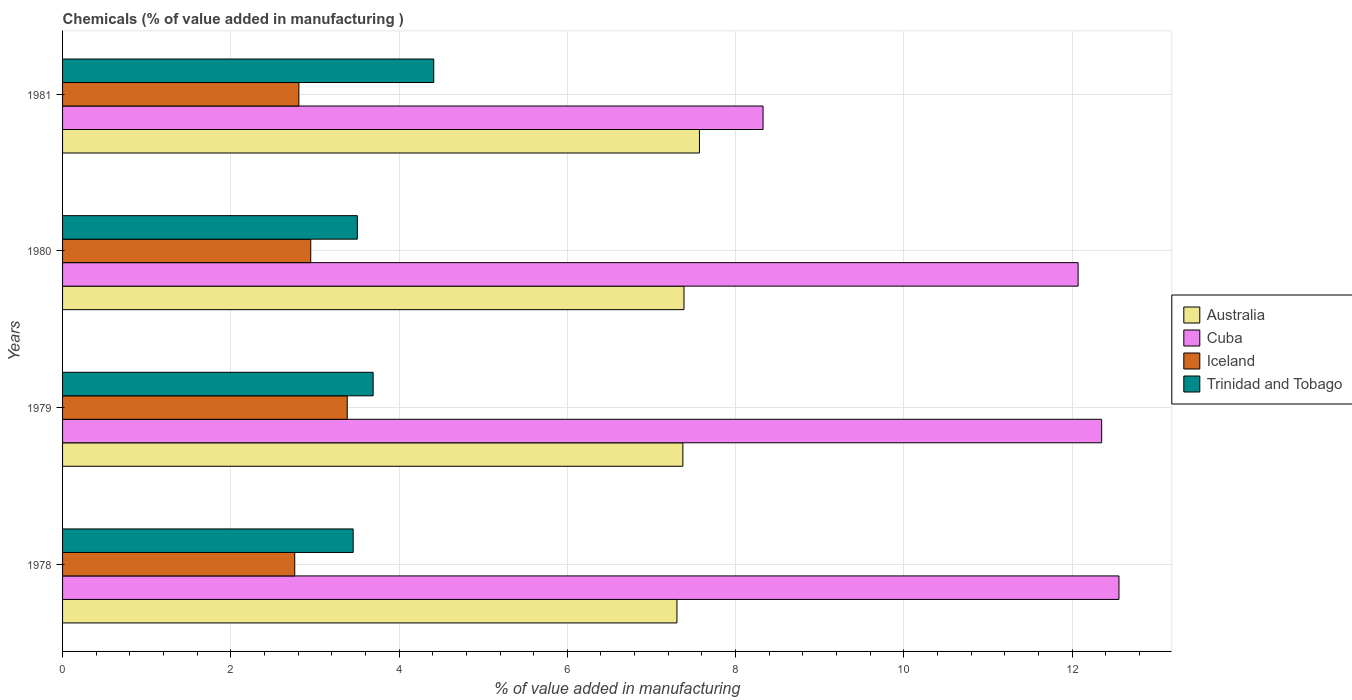How many groups of bars are there?
Give a very brief answer. 4. Are the number of bars per tick equal to the number of legend labels?
Your response must be concise. Yes. How many bars are there on the 1st tick from the top?
Give a very brief answer. 4. What is the value added in manufacturing chemicals in Australia in 1978?
Keep it short and to the point. 7.3. Across all years, what is the maximum value added in manufacturing chemicals in Cuba?
Your answer should be very brief. 12.56. Across all years, what is the minimum value added in manufacturing chemicals in Trinidad and Tobago?
Ensure brevity in your answer.  3.45. In which year was the value added in manufacturing chemicals in Cuba maximum?
Your response must be concise. 1978. In which year was the value added in manufacturing chemicals in Australia minimum?
Give a very brief answer. 1978. What is the total value added in manufacturing chemicals in Trinidad and Tobago in the graph?
Give a very brief answer. 15.06. What is the difference between the value added in manufacturing chemicals in Iceland in 1978 and that in 1979?
Your answer should be compact. -0.62. What is the difference between the value added in manufacturing chemicals in Trinidad and Tobago in 1981 and the value added in manufacturing chemicals in Cuba in 1980?
Give a very brief answer. -7.66. What is the average value added in manufacturing chemicals in Australia per year?
Your answer should be very brief. 7.41. In the year 1979, what is the difference between the value added in manufacturing chemicals in Cuba and value added in manufacturing chemicals in Trinidad and Tobago?
Provide a short and direct response. 8.66. In how many years, is the value added in manufacturing chemicals in Trinidad and Tobago greater than 10 %?
Offer a terse response. 0. What is the ratio of the value added in manufacturing chemicals in Trinidad and Tobago in 1978 to that in 1979?
Offer a terse response. 0.94. Is the value added in manufacturing chemicals in Cuba in 1978 less than that in 1981?
Your response must be concise. No. What is the difference between the highest and the second highest value added in manufacturing chemicals in Trinidad and Tobago?
Provide a short and direct response. 0.72. What is the difference between the highest and the lowest value added in manufacturing chemicals in Australia?
Give a very brief answer. 0.27. In how many years, is the value added in manufacturing chemicals in Australia greater than the average value added in manufacturing chemicals in Australia taken over all years?
Ensure brevity in your answer.  1. Is the sum of the value added in manufacturing chemicals in Trinidad and Tobago in 1978 and 1981 greater than the maximum value added in manufacturing chemicals in Cuba across all years?
Your answer should be very brief. No. What does the 1st bar from the top in 1979 represents?
Offer a very short reply. Trinidad and Tobago. What does the 3rd bar from the bottom in 1981 represents?
Make the answer very short. Iceland. How many bars are there?
Ensure brevity in your answer.  16. How many years are there in the graph?
Give a very brief answer. 4. What is the difference between two consecutive major ticks on the X-axis?
Your answer should be compact. 2. Are the values on the major ticks of X-axis written in scientific E-notation?
Your response must be concise. No. Does the graph contain any zero values?
Make the answer very short. No. Does the graph contain grids?
Provide a succinct answer. Yes. How many legend labels are there?
Your answer should be compact. 4. What is the title of the graph?
Provide a short and direct response. Chemicals (% of value added in manufacturing ). What is the label or title of the X-axis?
Offer a very short reply. % of value added in manufacturing. What is the % of value added in manufacturing of Australia in 1978?
Make the answer very short. 7.3. What is the % of value added in manufacturing in Cuba in 1978?
Your answer should be compact. 12.56. What is the % of value added in manufacturing in Iceland in 1978?
Your answer should be compact. 2.76. What is the % of value added in manufacturing in Trinidad and Tobago in 1978?
Your response must be concise. 3.45. What is the % of value added in manufacturing in Australia in 1979?
Your answer should be very brief. 7.37. What is the % of value added in manufacturing of Cuba in 1979?
Provide a short and direct response. 12.35. What is the % of value added in manufacturing of Iceland in 1979?
Ensure brevity in your answer.  3.38. What is the % of value added in manufacturing of Trinidad and Tobago in 1979?
Offer a very short reply. 3.69. What is the % of value added in manufacturing of Australia in 1980?
Keep it short and to the point. 7.39. What is the % of value added in manufacturing of Cuba in 1980?
Make the answer very short. 12.07. What is the % of value added in manufacturing in Iceland in 1980?
Provide a succinct answer. 2.95. What is the % of value added in manufacturing in Trinidad and Tobago in 1980?
Your answer should be very brief. 3.5. What is the % of value added in manufacturing of Australia in 1981?
Keep it short and to the point. 7.57. What is the % of value added in manufacturing in Cuba in 1981?
Provide a succinct answer. 8.33. What is the % of value added in manufacturing in Iceland in 1981?
Provide a succinct answer. 2.81. What is the % of value added in manufacturing in Trinidad and Tobago in 1981?
Offer a very short reply. 4.41. Across all years, what is the maximum % of value added in manufacturing of Australia?
Offer a very short reply. 7.57. Across all years, what is the maximum % of value added in manufacturing in Cuba?
Give a very brief answer. 12.56. Across all years, what is the maximum % of value added in manufacturing of Iceland?
Offer a terse response. 3.38. Across all years, what is the maximum % of value added in manufacturing of Trinidad and Tobago?
Your answer should be very brief. 4.41. Across all years, what is the minimum % of value added in manufacturing of Australia?
Offer a very short reply. 7.3. Across all years, what is the minimum % of value added in manufacturing in Cuba?
Make the answer very short. 8.33. Across all years, what is the minimum % of value added in manufacturing of Iceland?
Offer a terse response. 2.76. Across all years, what is the minimum % of value added in manufacturing of Trinidad and Tobago?
Your response must be concise. 3.45. What is the total % of value added in manufacturing in Australia in the graph?
Your answer should be very brief. 29.63. What is the total % of value added in manufacturing in Cuba in the graph?
Offer a very short reply. 45.31. What is the total % of value added in manufacturing of Iceland in the graph?
Keep it short and to the point. 11.9. What is the total % of value added in manufacturing of Trinidad and Tobago in the graph?
Give a very brief answer. 15.06. What is the difference between the % of value added in manufacturing in Australia in 1978 and that in 1979?
Keep it short and to the point. -0.07. What is the difference between the % of value added in manufacturing of Cuba in 1978 and that in 1979?
Keep it short and to the point. 0.21. What is the difference between the % of value added in manufacturing of Iceland in 1978 and that in 1979?
Provide a succinct answer. -0.62. What is the difference between the % of value added in manufacturing in Trinidad and Tobago in 1978 and that in 1979?
Offer a terse response. -0.24. What is the difference between the % of value added in manufacturing of Australia in 1978 and that in 1980?
Your answer should be very brief. -0.08. What is the difference between the % of value added in manufacturing in Cuba in 1978 and that in 1980?
Your answer should be compact. 0.49. What is the difference between the % of value added in manufacturing in Iceland in 1978 and that in 1980?
Ensure brevity in your answer.  -0.19. What is the difference between the % of value added in manufacturing of Trinidad and Tobago in 1978 and that in 1980?
Your answer should be very brief. -0.05. What is the difference between the % of value added in manufacturing of Australia in 1978 and that in 1981?
Keep it short and to the point. -0.27. What is the difference between the % of value added in manufacturing in Cuba in 1978 and that in 1981?
Ensure brevity in your answer.  4.23. What is the difference between the % of value added in manufacturing in Iceland in 1978 and that in 1981?
Keep it short and to the point. -0.05. What is the difference between the % of value added in manufacturing in Trinidad and Tobago in 1978 and that in 1981?
Provide a short and direct response. -0.96. What is the difference between the % of value added in manufacturing of Australia in 1979 and that in 1980?
Offer a terse response. -0.01. What is the difference between the % of value added in manufacturing in Cuba in 1979 and that in 1980?
Provide a succinct answer. 0.28. What is the difference between the % of value added in manufacturing of Iceland in 1979 and that in 1980?
Keep it short and to the point. 0.43. What is the difference between the % of value added in manufacturing of Trinidad and Tobago in 1979 and that in 1980?
Offer a terse response. 0.19. What is the difference between the % of value added in manufacturing of Australia in 1979 and that in 1981?
Your answer should be very brief. -0.2. What is the difference between the % of value added in manufacturing of Cuba in 1979 and that in 1981?
Your answer should be compact. 4.03. What is the difference between the % of value added in manufacturing of Iceland in 1979 and that in 1981?
Offer a terse response. 0.57. What is the difference between the % of value added in manufacturing in Trinidad and Tobago in 1979 and that in 1981?
Your answer should be compact. -0.72. What is the difference between the % of value added in manufacturing of Australia in 1980 and that in 1981?
Provide a short and direct response. -0.18. What is the difference between the % of value added in manufacturing of Cuba in 1980 and that in 1981?
Give a very brief answer. 3.75. What is the difference between the % of value added in manufacturing of Iceland in 1980 and that in 1981?
Your response must be concise. 0.14. What is the difference between the % of value added in manufacturing in Trinidad and Tobago in 1980 and that in 1981?
Your answer should be compact. -0.91. What is the difference between the % of value added in manufacturing in Australia in 1978 and the % of value added in manufacturing in Cuba in 1979?
Provide a short and direct response. -5.05. What is the difference between the % of value added in manufacturing of Australia in 1978 and the % of value added in manufacturing of Iceland in 1979?
Keep it short and to the point. 3.92. What is the difference between the % of value added in manufacturing of Australia in 1978 and the % of value added in manufacturing of Trinidad and Tobago in 1979?
Your answer should be very brief. 3.61. What is the difference between the % of value added in manufacturing of Cuba in 1978 and the % of value added in manufacturing of Iceland in 1979?
Your answer should be compact. 9.17. What is the difference between the % of value added in manufacturing in Cuba in 1978 and the % of value added in manufacturing in Trinidad and Tobago in 1979?
Make the answer very short. 8.87. What is the difference between the % of value added in manufacturing in Iceland in 1978 and the % of value added in manufacturing in Trinidad and Tobago in 1979?
Ensure brevity in your answer.  -0.93. What is the difference between the % of value added in manufacturing of Australia in 1978 and the % of value added in manufacturing of Cuba in 1980?
Provide a short and direct response. -4.77. What is the difference between the % of value added in manufacturing of Australia in 1978 and the % of value added in manufacturing of Iceland in 1980?
Make the answer very short. 4.35. What is the difference between the % of value added in manufacturing of Australia in 1978 and the % of value added in manufacturing of Trinidad and Tobago in 1980?
Make the answer very short. 3.8. What is the difference between the % of value added in manufacturing of Cuba in 1978 and the % of value added in manufacturing of Iceland in 1980?
Offer a very short reply. 9.61. What is the difference between the % of value added in manufacturing of Cuba in 1978 and the % of value added in manufacturing of Trinidad and Tobago in 1980?
Make the answer very short. 9.05. What is the difference between the % of value added in manufacturing of Iceland in 1978 and the % of value added in manufacturing of Trinidad and Tobago in 1980?
Offer a terse response. -0.74. What is the difference between the % of value added in manufacturing in Australia in 1978 and the % of value added in manufacturing in Cuba in 1981?
Make the answer very short. -1.02. What is the difference between the % of value added in manufacturing of Australia in 1978 and the % of value added in manufacturing of Iceland in 1981?
Offer a very short reply. 4.49. What is the difference between the % of value added in manufacturing of Australia in 1978 and the % of value added in manufacturing of Trinidad and Tobago in 1981?
Offer a terse response. 2.89. What is the difference between the % of value added in manufacturing of Cuba in 1978 and the % of value added in manufacturing of Iceland in 1981?
Provide a short and direct response. 9.75. What is the difference between the % of value added in manufacturing of Cuba in 1978 and the % of value added in manufacturing of Trinidad and Tobago in 1981?
Your answer should be compact. 8.15. What is the difference between the % of value added in manufacturing of Iceland in 1978 and the % of value added in manufacturing of Trinidad and Tobago in 1981?
Ensure brevity in your answer.  -1.65. What is the difference between the % of value added in manufacturing in Australia in 1979 and the % of value added in manufacturing in Cuba in 1980?
Your answer should be compact. -4.7. What is the difference between the % of value added in manufacturing in Australia in 1979 and the % of value added in manufacturing in Iceland in 1980?
Offer a very short reply. 4.42. What is the difference between the % of value added in manufacturing of Australia in 1979 and the % of value added in manufacturing of Trinidad and Tobago in 1980?
Your response must be concise. 3.87. What is the difference between the % of value added in manufacturing in Cuba in 1979 and the % of value added in manufacturing in Iceland in 1980?
Keep it short and to the point. 9.4. What is the difference between the % of value added in manufacturing in Cuba in 1979 and the % of value added in manufacturing in Trinidad and Tobago in 1980?
Your answer should be very brief. 8.85. What is the difference between the % of value added in manufacturing in Iceland in 1979 and the % of value added in manufacturing in Trinidad and Tobago in 1980?
Provide a short and direct response. -0.12. What is the difference between the % of value added in manufacturing of Australia in 1979 and the % of value added in manufacturing of Cuba in 1981?
Provide a succinct answer. -0.95. What is the difference between the % of value added in manufacturing of Australia in 1979 and the % of value added in manufacturing of Iceland in 1981?
Provide a succinct answer. 4.56. What is the difference between the % of value added in manufacturing of Australia in 1979 and the % of value added in manufacturing of Trinidad and Tobago in 1981?
Provide a succinct answer. 2.96. What is the difference between the % of value added in manufacturing of Cuba in 1979 and the % of value added in manufacturing of Iceland in 1981?
Make the answer very short. 9.54. What is the difference between the % of value added in manufacturing in Cuba in 1979 and the % of value added in manufacturing in Trinidad and Tobago in 1981?
Your answer should be very brief. 7.94. What is the difference between the % of value added in manufacturing of Iceland in 1979 and the % of value added in manufacturing of Trinidad and Tobago in 1981?
Ensure brevity in your answer.  -1.03. What is the difference between the % of value added in manufacturing in Australia in 1980 and the % of value added in manufacturing in Cuba in 1981?
Offer a very short reply. -0.94. What is the difference between the % of value added in manufacturing in Australia in 1980 and the % of value added in manufacturing in Iceland in 1981?
Your answer should be very brief. 4.58. What is the difference between the % of value added in manufacturing of Australia in 1980 and the % of value added in manufacturing of Trinidad and Tobago in 1981?
Give a very brief answer. 2.97. What is the difference between the % of value added in manufacturing in Cuba in 1980 and the % of value added in manufacturing in Iceland in 1981?
Provide a succinct answer. 9.26. What is the difference between the % of value added in manufacturing of Cuba in 1980 and the % of value added in manufacturing of Trinidad and Tobago in 1981?
Offer a very short reply. 7.66. What is the difference between the % of value added in manufacturing in Iceland in 1980 and the % of value added in manufacturing in Trinidad and Tobago in 1981?
Provide a succinct answer. -1.46. What is the average % of value added in manufacturing of Australia per year?
Offer a very short reply. 7.41. What is the average % of value added in manufacturing in Cuba per year?
Keep it short and to the point. 11.33. What is the average % of value added in manufacturing in Iceland per year?
Provide a succinct answer. 2.98. What is the average % of value added in manufacturing of Trinidad and Tobago per year?
Offer a very short reply. 3.77. In the year 1978, what is the difference between the % of value added in manufacturing in Australia and % of value added in manufacturing in Cuba?
Ensure brevity in your answer.  -5.25. In the year 1978, what is the difference between the % of value added in manufacturing in Australia and % of value added in manufacturing in Iceland?
Offer a very short reply. 4.54. In the year 1978, what is the difference between the % of value added in manufacturing in Australia and % of value added in manufacturing in Trinidad and Tobago?
Make the answer very short. 3.85. In the year 1978, what is the difference between the % of value added in manufacturing in Cuba and % of value added in manufacturing in Iceland?
Provide a short and direct response. 9.8. In the year 1978, what is the difference between the % of value added in manufacturing of Cuba and % of value added in manufacturing of Trinidad and Tobago?
Give a very brief answer. 9.1. In the year 1978, what is the difference between the % of value added in manufacturing of Iceland and % of value added in manufacturing of Trinidad and Tobago?
Offer a very short reply. -0.69. In the year 1979, what is the difference between the % of value added in manufacturing of Australia and % of value added in manufacturing of Cuba?
Provide a short and direct response. -4.98. In the year 1979, what is the difference between the % of value added in manufacturing of Australia and % of value added in manufacturing of Iceland?
Offer a terse response. 3.99. In the year 1979, what is the difference between the % of value added in manufacturing of Australia and % of value added in manufacturing of Trinidad and Tobago?
Your answer should be very brief. 3.68. In the year 1979, what is the difference between the % of value added in manufacturing in Cuba and % of value added in manufacturing in Iceland?
Keep it short and to the point. 8.97. In the year 1979, what is the difference between the % of value added in manufacturing of Cuba and % of value added in manufacturing of Trinidad and Tobago?
Your response must be concise. 8.66. In the year 1979, what is the difference between the % of value added in manufacturing in Iceland and % of value added in manufacturing in Trinidad and Tobago?
Offer a very short reply. -0.31. In the year 1980, what is the difference between the % of value added in manufacturing of Australia and % of value added in manufacturing of Cuba?
Ensure brevity in your answer.  -4.68. In the year 1980, what is the difference between the % of value added in manufacturing of Australia and % of value added in manufacturing of Iceland?
Your answer should be very brief. 4.44. In the year 1980, what is the difference between the % of value added in manufacturing in Australia and % of value added in manufacturing in Trinidad and Tobago?
Make the answer very short. 3.88. In the year 1980, what is the difference between the % of value added in manufacturing in Cuba and % of value added in manufacturing in Iceland?
Your answer should be very brief. 9.12. In the year 1980, what is the difference between the % of value added in manufacturing of Cuba and % of value added in manufacturing of Trinidad and Tobago?
Make the answer very short. 8.57. In the year 1980, what is the difference between the % of value added in manufacturing in Iceland and % of value added in manufacturing in Trinidad and Tobago?
Your answer should be compact. -0.55. In the year 1981, what is the difference between the % of value added in manufacturing in Australia and % of value added in manufacturing in Cuba?
Give a very brief answer. -0.76. In the year 1981, what is the difference between the % of value added in manufacturing in Australia and % of value added in manufacturing in Iceland?
Provide a succinct answer. 4.76. In the year 1981, what is the difference between the % of value added in manufacturing of Australia and % of value added in manufacturing of Trinidad and Tobago?
Your answer should be compact. 3.16. In the year 1981, what is the difference between the % of value added in manufacturing in Cuba and % of value added in manufacturing in Iceland?
Your response must be concise. 5.52. In the year 1981, what is the difference between the % of value added in manufacturing of Cuba and % of value added in manufacturing of Trinidad and Tobago?
Provide a succinct answer. 3.91. In the year 1981, what is the difference between the % of value added in manufacturing of Iceland and % of value added in manufacturing of Trinidad and Tobago?
Provide a short and direct response. -1.6. What is the ratio of the % of value added in manufacturing of Australia in 1978 to that in 1979?
Ensure brevity in your answer.  0.99. What is the ratio of the % of value added in manufacturing in Cuba in 1978 to that in 1979?
Provide a short and direct response. 1.02. What is the ratio of the % of value added in manufacturing of Iceland in 1978 to that in 1979?
Offer a very short reply. 0.82. What is the ratio of the % of value added in manufacturing in Trinidad and Tobago in 1978 to that in 1979?
Your response must be concise. 0.94. What is the ratio of the % of value added in manufacturing in Australia in 1978 to that in 1980?
Make the answer very short. 0.99. What is the ratio of the % of value added in manufacturing of Cuba in 1978 to that in 1980?
Offer a terse response. 1.04. What is the ratio of the % of value added in manufacturing in Iceland in 1978 to that in 1980?
Make the answer very short. 0.94. What is the ratio of the % of value added in manufacturing in Trinidad and Tobago in 1978 to that in 1980?
Provide a short and direct response. 0.99. What is the ratio of the % of value added in manufacturing of Australia in 1978 to that in 1981?
Provide a short and direct response. 0.96. What is the ratio of the % of value added in manufacturing of Cuba in 1978 to that in 1981?
Make the answer very short. 1.51. What is the ratio of the % of value added in manufacturing in Iceland in 1978 to that in 1981?
Offer a terse response. 0.98. What is the ratio of the % of value added in manufacturing of Trinidad and Tobago in 1978 to that in 1981?
Offer a very short reply. 0.78. What is the ratio of the % of value added in manufacturing of Australia in 1979 to that in 1980?
Offer a very short reply. 1. What is the ratio of the % of value added in manufacturing in Cuba in 1979 to that in 1980?
Give a very brief answer. 1.02. What is the ratio of the % of value added in manufacturing in Iceland in 1979 to that in 1980?
Provide a succinct answer. 1.15. What is the ratio of the % of value added in manufacturing in Trinidad and Tobago in 1979 to that in 1980?
Provide a short and direct response. 1.05. What is the ratio of the % of value added in manufacturing in Cuba in 1979 to that in 1981?
Give a very brief answer. 1.48. What is the ratio of the % of value added in manufacturing of Iceland in 1979 to that in 1981?
Ensure brevity in your answer.  1.2. What is the ratio of the % of value added in manufacturing in Trinidad and Tobago in 1979 to that in 1981?
Your response must be concise. 0.84. What is the ratio of the % of value added in manufacturing in Australia in 1980 to that in 1981?
Provide a succinct answer. 0.98. What is the ratio of the % of value added in manufacturing of Cuba in 1980 to that in 1981?
Your answer should be compact. 1.45. What is the ratio of the % of value added in manufacturing in Iceland in 1980 to that in 1981?
Provide a succinct answer. 1.05. What is the ratio of the % of value added in manufacturing of Trinidad and Tobago in 1980 to that in 1981?
Provide a succinct answer. 0.79. What is the difference between the highest and the second highest % of value added in manufacturing of Australia?
Provide a short and direct response. 0.18. What is the difference between the highest and the second highest % of value added in manufacturing of Cuba?
Offer a terse response. 0.21. What is the difference between the highest and the second highest % of value added in manufacturing of Iceland?
Provide a succinct answer. 0.43. What is the difference between the highest and the second highest % of value added in manufacturing of Trinidad and Tobago?
Ensure brevity in your answer.  0.72. What is the difference between the highest and the lowest % of value added in manufacturing of Australia?
Give a very brief answer. 0.27. What is the difference between the highest and the lowest % of value added in manufacturing in Cuba?
Offer a very short reply. 4.23. What is the difference between the highest and the lowest % of value added in manufacturing in Iceland?
Offer a terse response. 0.62. What is the difference between the highest and the lowest % of value added in manufacturing in Trinidad and Tobago?
Give a very brief answer. 0.96. 